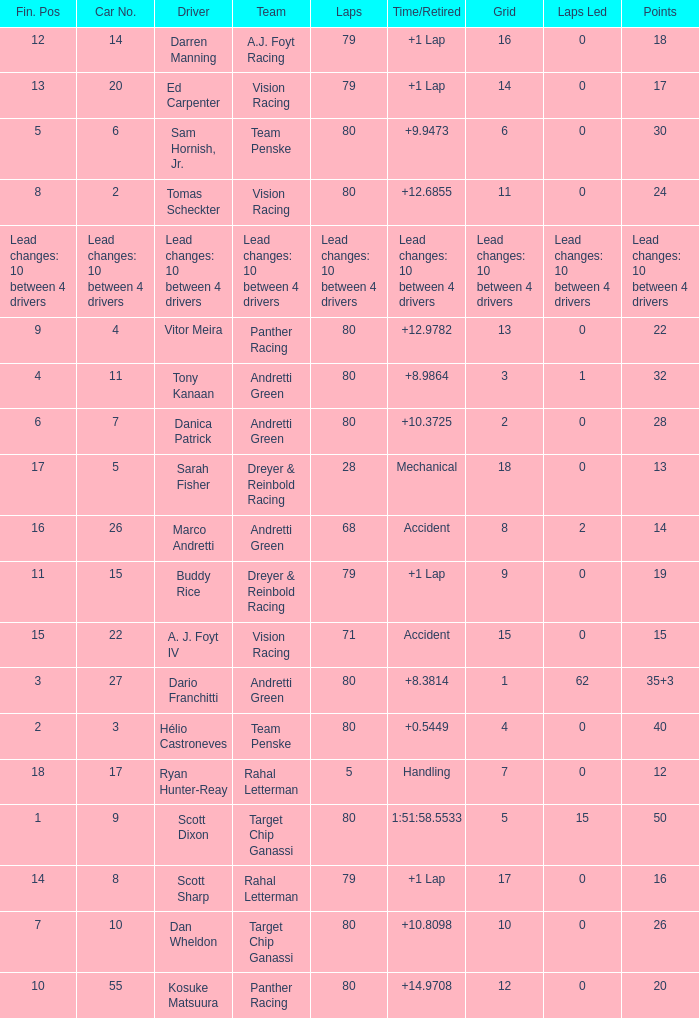What is the total number of points for driver kosuke matsuura? 20.0. 